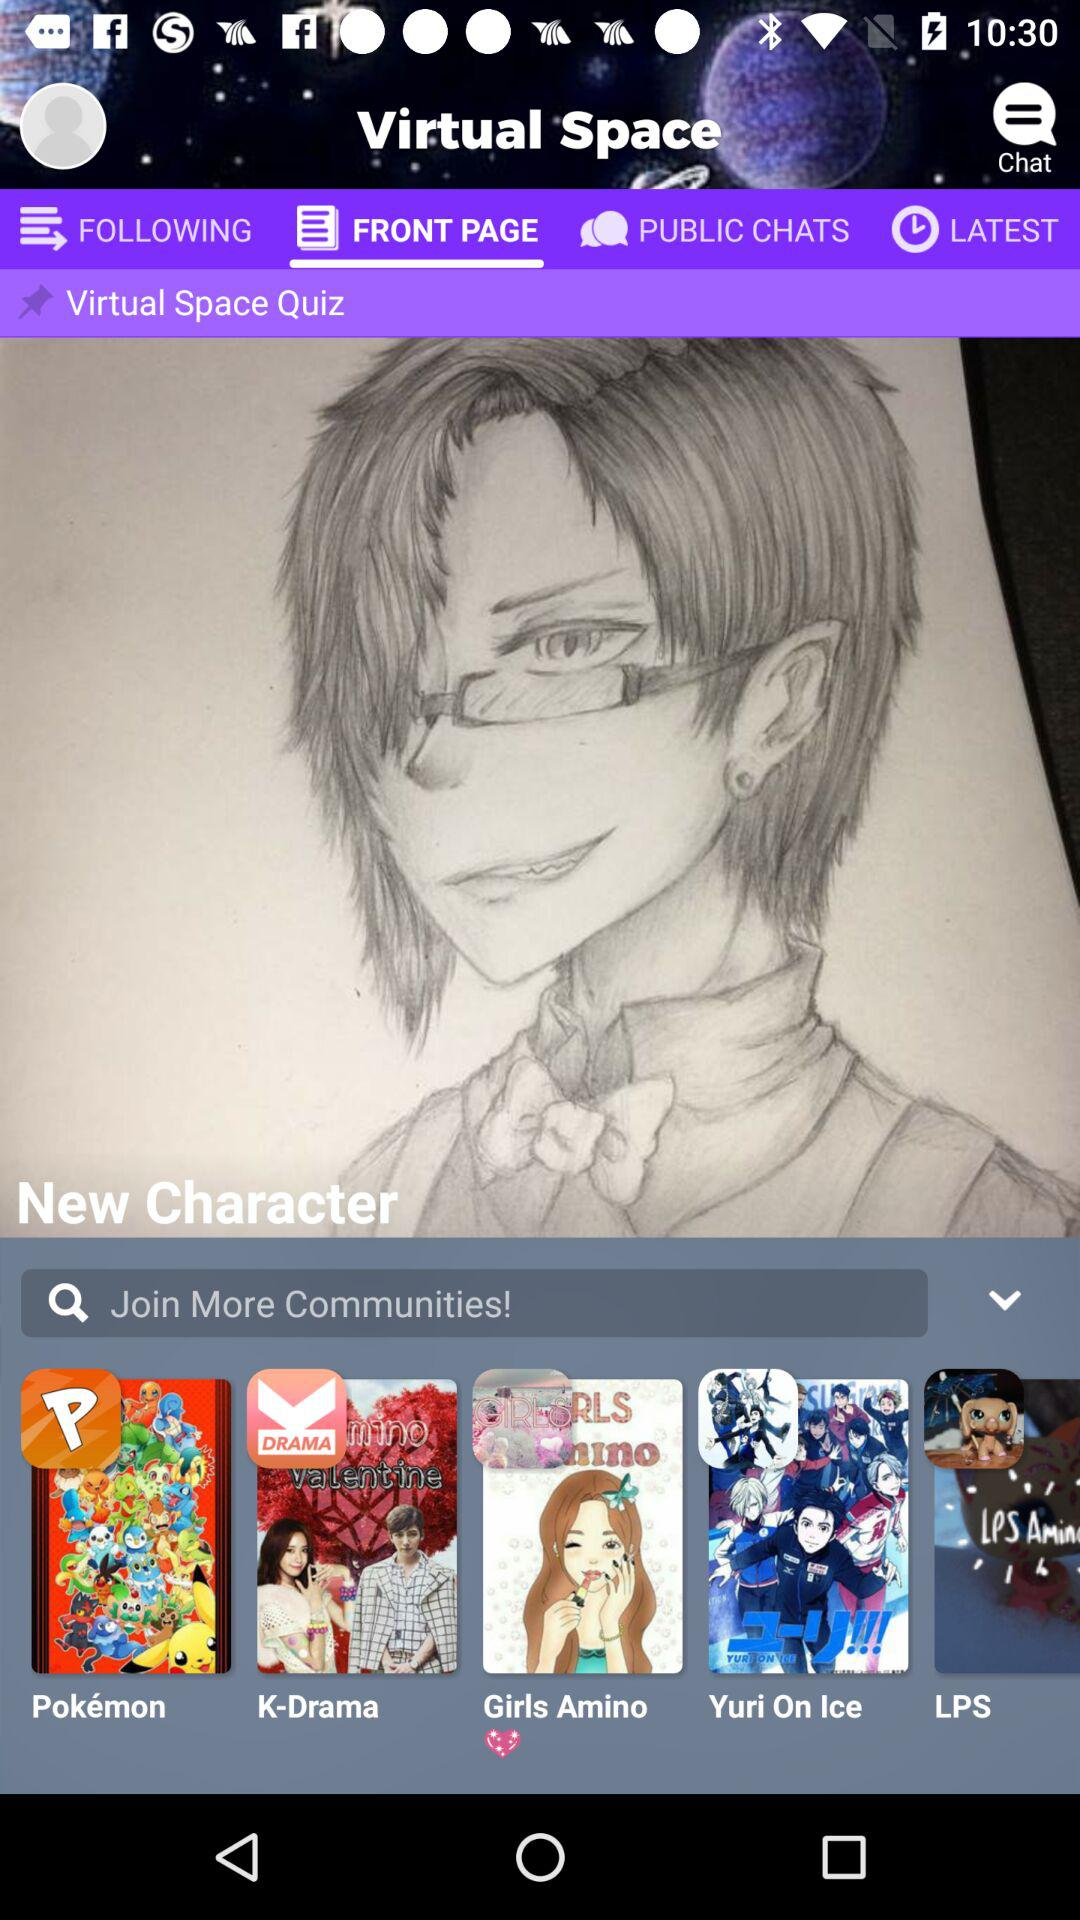Which tab is selected? The selected tab is "FRONT PAGE". 